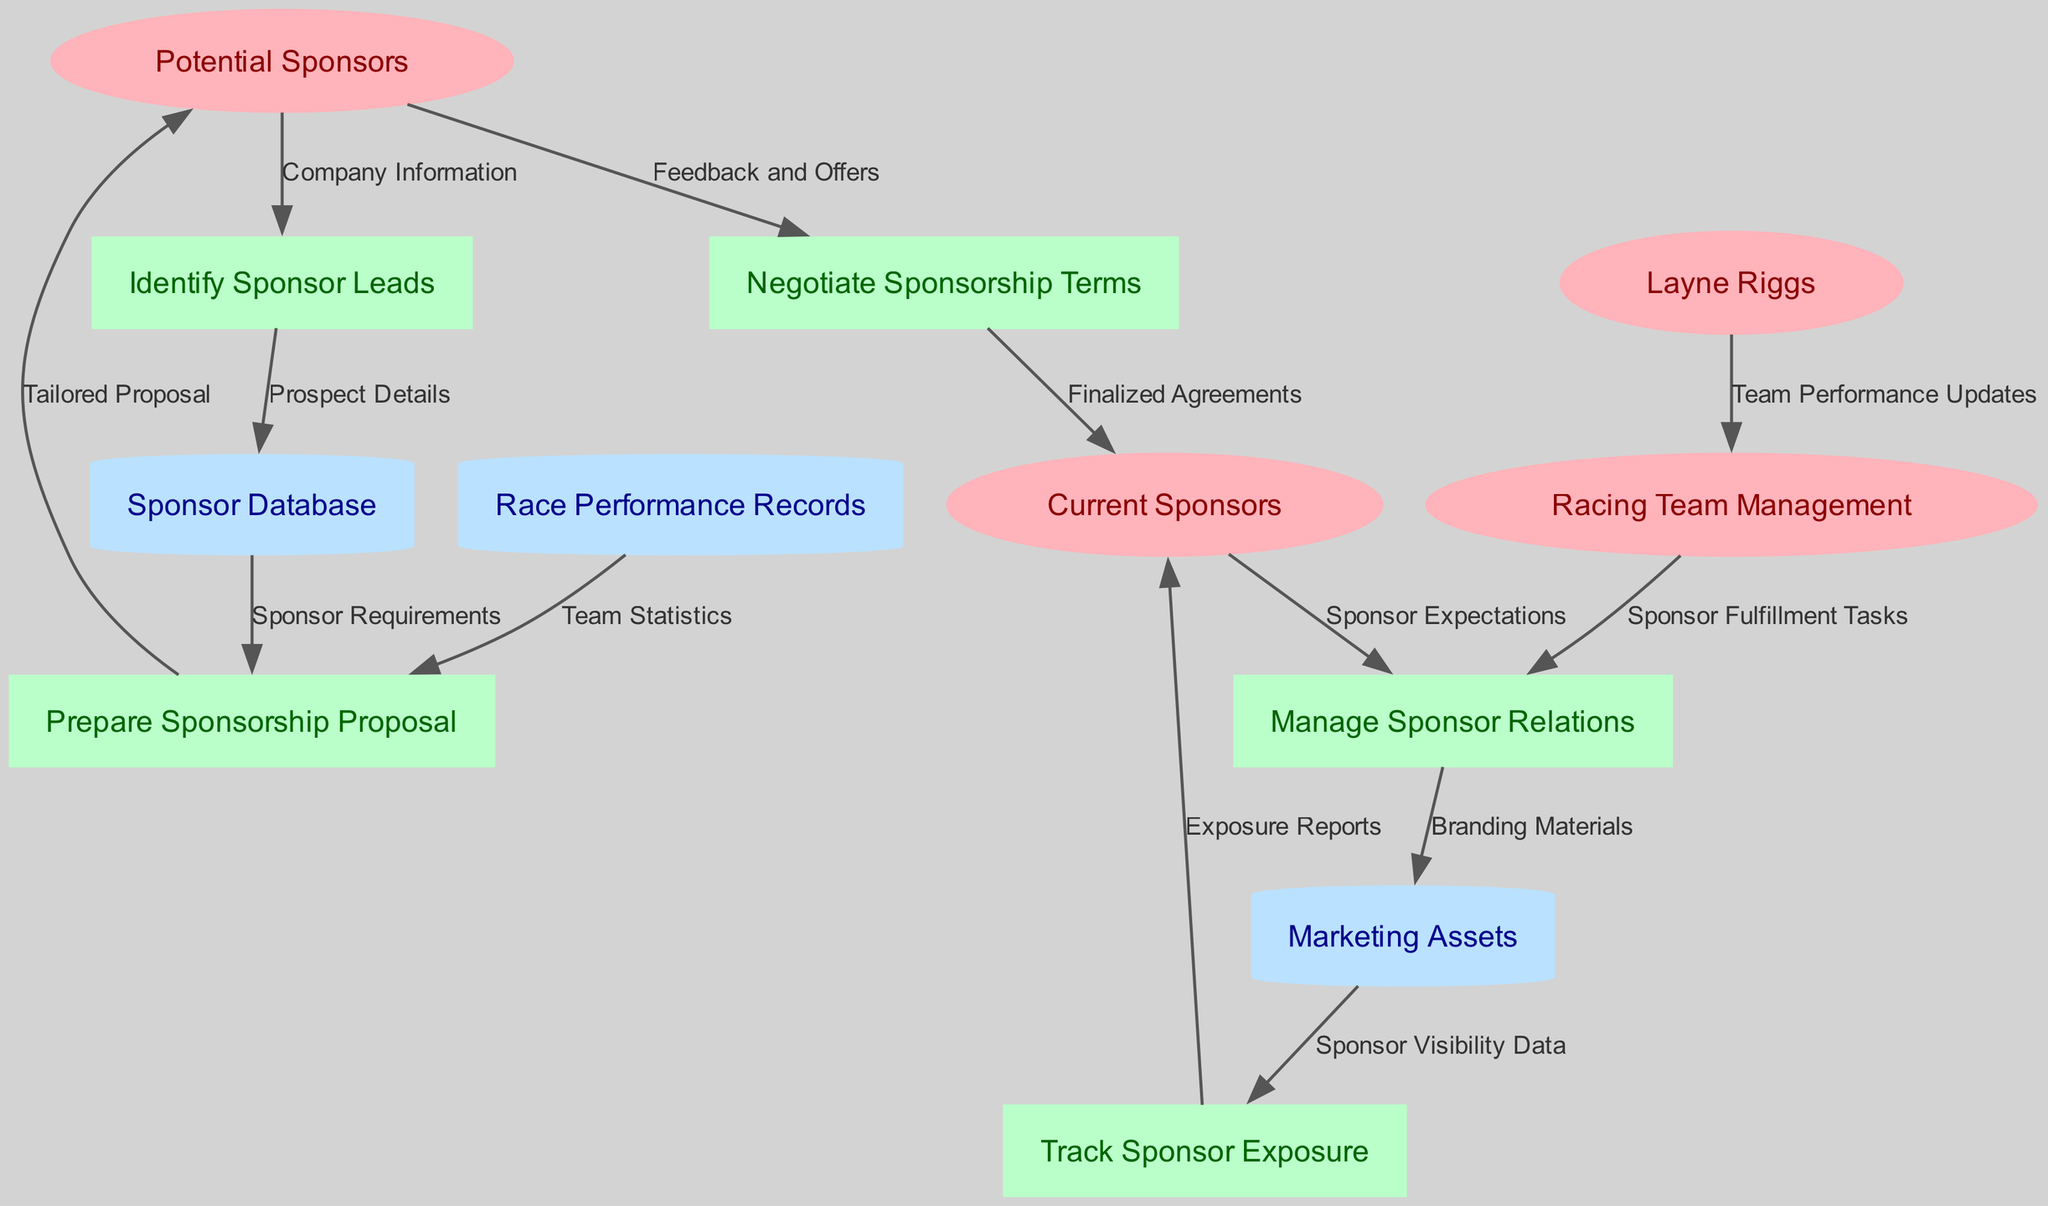What are the external entities in this diagram? The external entities are shown as ellipses in the diagram. They include "Potential Sponsors," "Current Sponsors," "Layne Riggs," and "Racing Team Management."
Answer: Potential Sponsors, Current Sponsors, Layne Riggs, Racing Team Management How many processes are represented in the diagram? The number of processes can be counted from the rectangular nodes, which include "Identify Sponsor Leads," "Prepare Sponsorship Proposal," "Negotiate Sponsorship Terms," "Manage Sponsor Relations," and "Track Sponsor Exposure." There are five processes in total.
Answer: 5 Which process follows "Prepare Sponsorship Proposal"? By analyzing the directed edges, we can track that the flow moves from "Prepare Sponsorship Proposal" to "Potential Sponsors." This indicates that "Prepare Sponsorship Proposal" is followed by sending out "Tailored Proposal" to "Potential Sponsors."
Answer: Potential Sponsors What type of relationship exists between "Negotiate Sponsorship Terms" and "Current Sponsors"? The relationship is a directed one where "Negotiate Sponsorship Terms" sends "Finalized Agreements" to "Current Sponsors." This indicates a flow from negotiation to an established sponsor relationship.
Answer: Finalized Agreements Which external entity provides feedback to "Negotiate Sponsorship Terms"? Tracing the data flow, "Potential Sponsors" are shown to provide "Feedback and Offers" to "Negotiate Sponsorship Terms." This indicates that potential sponsors' responses are essential during negotiations.
Answer: Potential Sponsors What information does the "Sponsor Database" provide to the "Prepare Sponsorship Proposal" process? The "Sponsor Database" provides "Sponsor Requirements," which are necessary for tailoring proposals for potential sponsors. This flow indicates the data needed from the database to create effective proposals.
Answer: Sponsor Requirements How is sponsor visibility data utilized in the process? The "Marketing Assets" flow into "Track Sponsor Exposure," which utilizes "Sponsor Visibility Data" to create "Exposure Reports" sent to "Current Sponsors." This means visibility data affects how sponsors perceive their exposure.
Answer: Exposure Reports What is the final output of the "Track Sponsor Exposure" process? The output from "Track Sponsor Exposure" is "Exposure Reports" that are directed to "Current Sponsors." This shows the relationship between tracking outcomes and communication with existing sponsors.
Answer: Exposure Reports From which external entity do team performance updates originate? The flow in the diagram indicates that "Layne Riggs" sends "Team Performance Updates" to "Racing Team Management." This establishes Layne as a communicator of performance information relevant to sponsorship.
Answer: Layne Riggs 